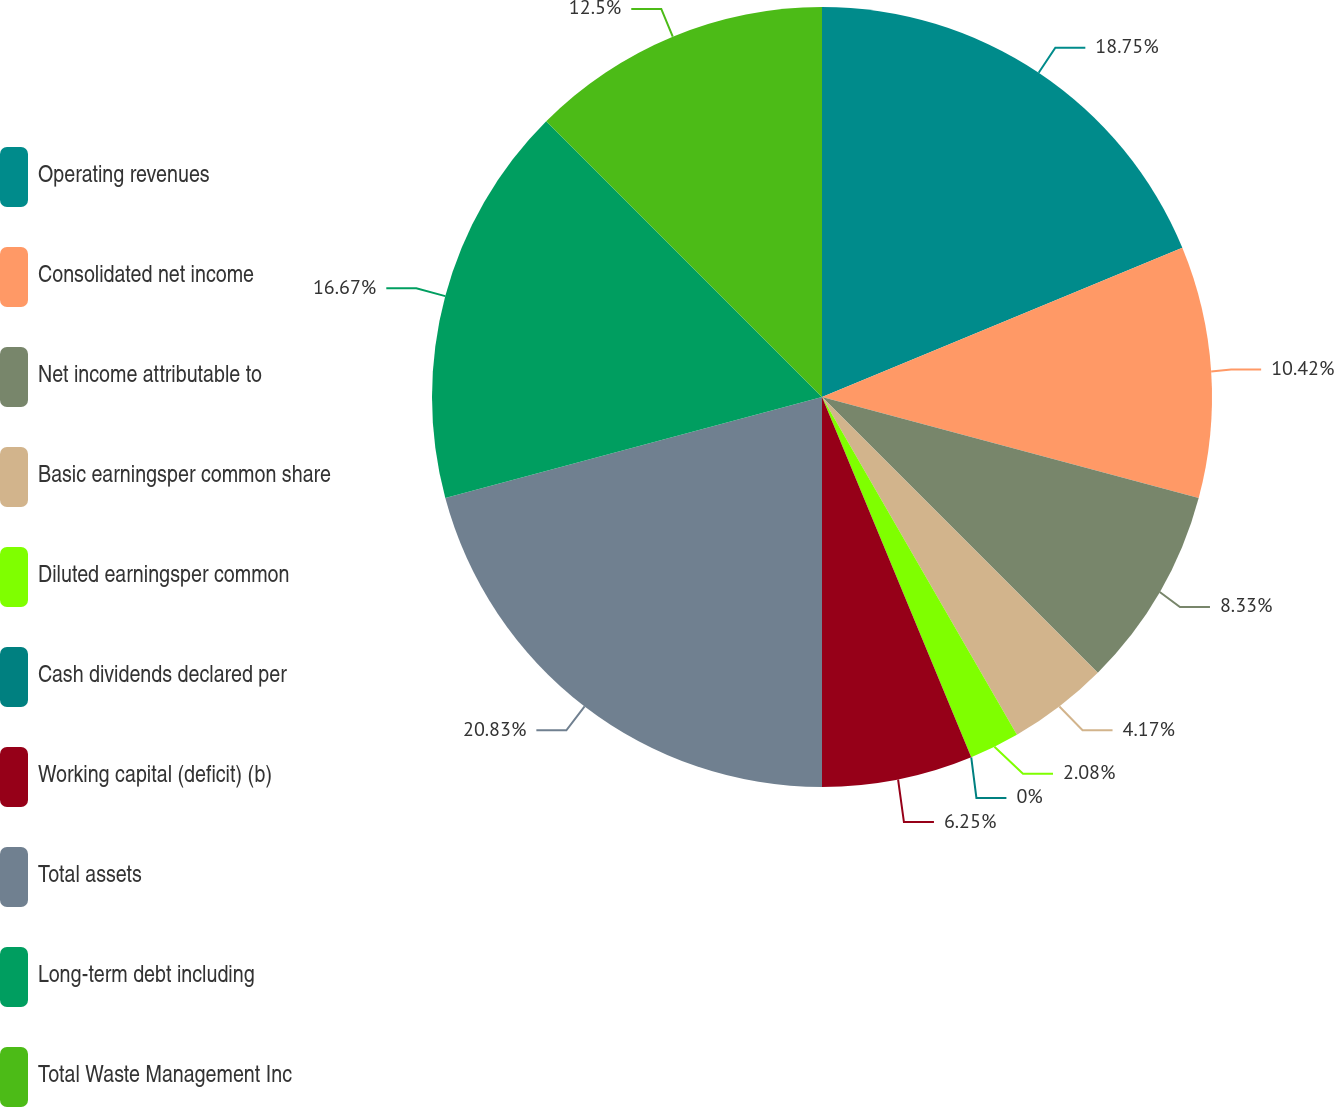Convert chart. <chart><loc_0><loc_0><loc_500><loc_500><pie_chart><fcel>Operating revenues<fcel>Consolidated net income<fcel>Net income attributable to<fcel>Basic earningsper common share<fcel>Diluted earningsper common<fcel>Cash dividends declared per<fcel>Working capital (deficit) (b)<fcel>Total assets<fcel>Long-term debt including<fcel>Total Waste Management Inc<nl><fcel>18.75%<fcel>10.42%<fcel>8.33%<fcel>4.17%<fcel>2.08%<fcel>0.0%<fcel>6.25%<fcel>20.83%<fcel>16.67%<fcel>12.5%<nl></chart> 